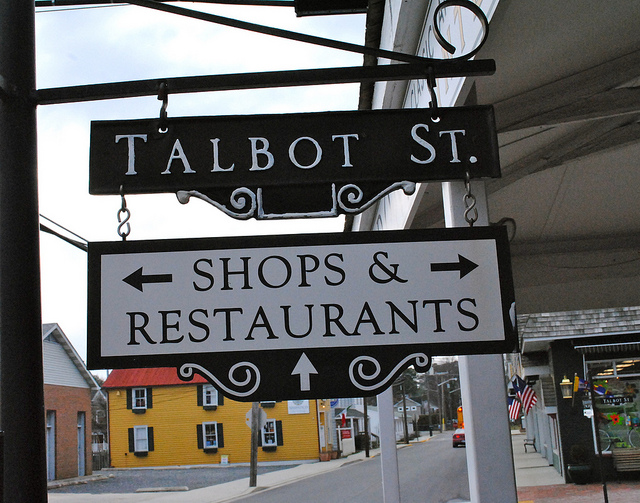Is Talbot St. ideal for pedestrians looking to explore local stores? Yes, Talbot St. seems to be pedestrian-friendly with sidewalks and street signs indicating the presence of shops and restaurants, making it an inviting location for a leisurely stroll while exploring local storefronts. 